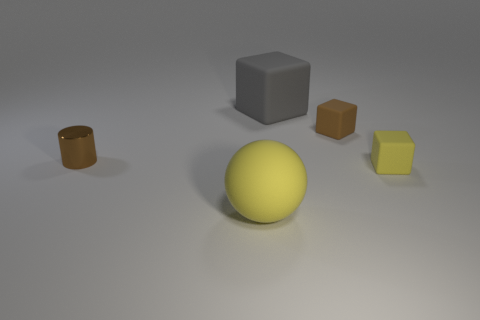What might be the purpose of arranging these objects like this? The arrangement of the objects might be for a display or an experiment in visual composition, color contrast, and the study of geometry and shadows in photography or rendering.  Can you guess what materials these objects are made of based on their appearance? Based on appearance, the cylinder and the blocks might be made of a matte plastic material, and the spherical object appears to have a smoother, possibly reflective surface that could be metal or polished stone. 